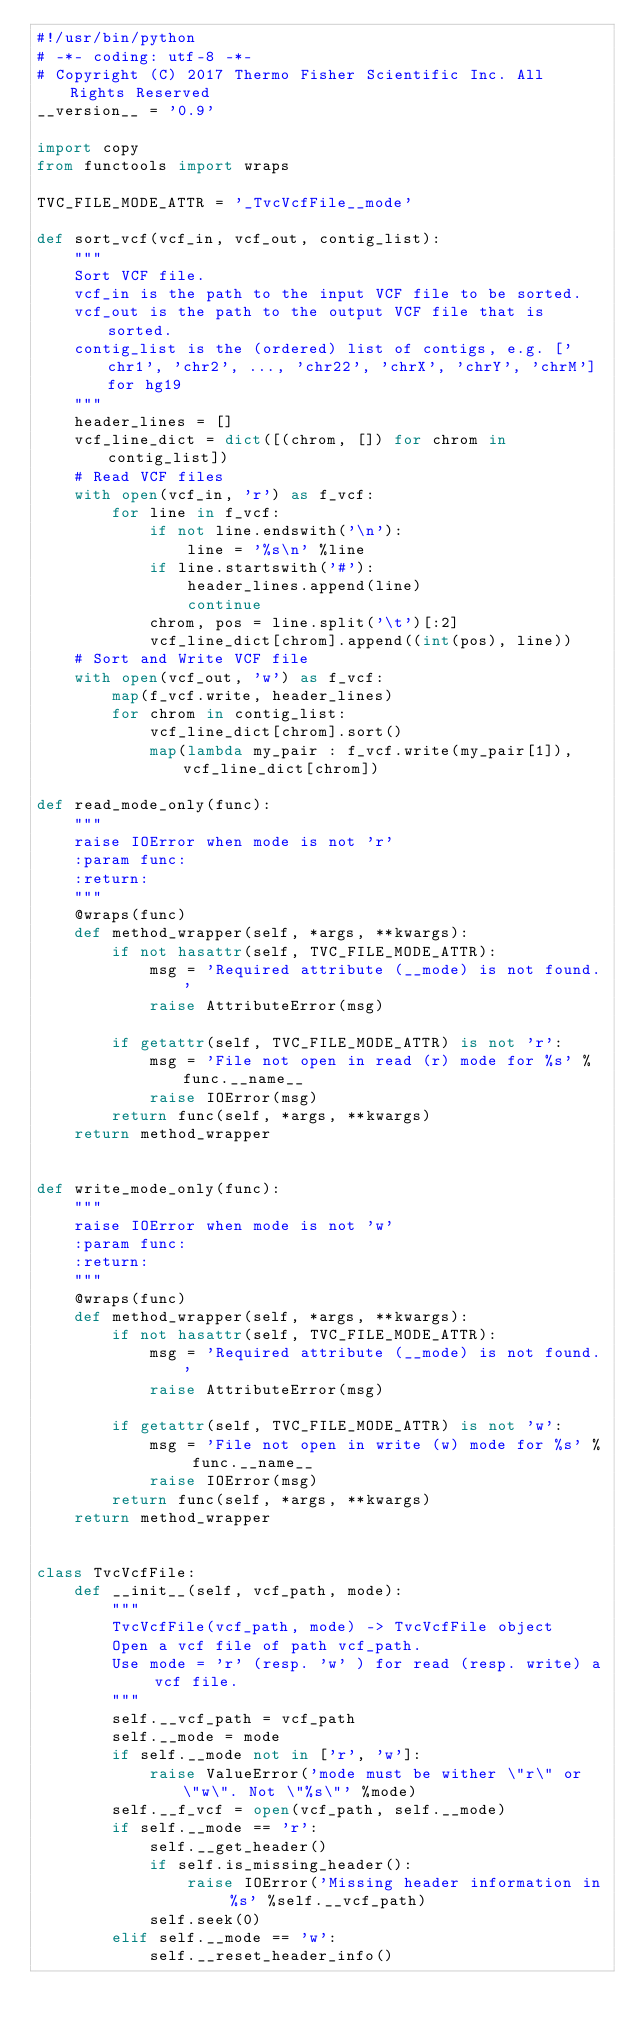Convert code to text. <code><loc_0><loc_0><loc_500><loc_500><_Python_>#!/usr/bin/python
# -*- coding: utf-8 -*-
# Copyright (C) 2017 Thermo Fisher Scientific Inc. All Rights Reserved
__version__ = '0.9'

import copy
from functools import wraps

TVC_FILE_MODE_ATTR = '_TvcVcfFile__mode'

def sort_vcf(vcf_in, vcf_out, contig_list):
    """
    Sort VCF file.
    vcf_in is the path to the input VCF file to be sorted.
    vcf_out is the path to the output VCF file that is sorted.
    contig_list is the (ordered) list of contigs, e.g. ['chr1', 'chr2', ..., 'chr22', 'chrX', 'chrY', 'chrM'] for hg19
    """    
    header_lines = []
    vcf_line_dict = dict([(chrom, []) for chrom in contig_list])
    # Read VCF files
    with open(vcf_in, 'r') as f_vcf:
        for line in f_vcf:
            if not line.endswith('\n'):
                line = '%s\n' %line
            if line.startswith('#'):
                header_lines.append(line)
                continue
            chrom, pos = line.split('\t')[:2]
            vcf_line_dict[chrom].append((int(pos), line))
    # Sort and Write VCF file
    with open(vcf_out, 'w') as f_vcf:
        map(f_vcf.write, header_lines)
        for chrom in contig_list:
            vcf_line_dict[chrom].sort()
            map(lambda my_pair : f_vcf.write(my_pair[1]), vcf_line_dict[chrom])

def read_mode_only(func):
    """
    raise IOError when mode is not 'r'
    :param func:
    :return:
    """
    @wraps(func)
    def method_wrapper(self, *args, **kwargs):
        if not hasattr(self, TVC_FILE_MODE_ATTR):
            msg = 'Required attribute (__mode) is not found.'
            raise AttributeError(msg)

        if getattr(self, TVC_FILE_MODE_ATTR) is not 'r':
            msg = 'File not open in read (r) mode for %s' % func.__name__
            raise IOError(msg)
        return func(self, *args, **kwargs)
    return method_wrapper


def write_mode_only(func):
    """
    raise IOError when mode is not 'w'
    :param func:
    :return:
    """
    @wraps(func)
    def method_wrapper(self, *args, **kwargs):
        if not hasattr(self, TVC_FILE_MODE_ATTR):
            msg = 'Required attribute (__mode) is not found.'
            raise AttributeError(msg)

        if getattr(self, TVC_FILE_MODE_ATTR) is not 'w':
            msg = 'File not open in write (w) mode for %s' % func.__name__
            raise IOError(msg)
        return func(self, *args, **kwargs)
    return method_wrapper


class TvcVcfFile:
    def __init__(self, vcf_path, mode):
        """
        TvcVcfFile(vcf_path, mode) -> TvcVcfFile object
        Open a vcf file of path vcf_path.
        Use mode = 'r' (resp. 'w' ) for read (resp. write) a vcf file.
        """
        self.__vcf_path = vcf_path
        self.__mode = mode
        if self.__mode not in ['r', 'w']:
            raise ValueError('mode must be wither \"r\" or \"w\". Not \"%s\"' %mode)
        self.__f_vcf = open(vcf_path, self.__mode)
        if self.__mode == 'r':
            self.__get_header()
            if self.is_missing_header():
                raise IOError('Missing header information in %s' %self.__vcf_path)
            self.seek(0)
        elif self.__mode == 'w':
            self.__reset_header_info()</code> 